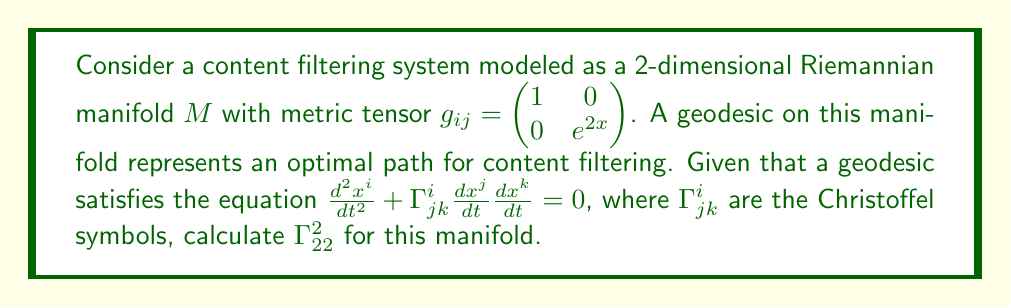Teach me how to tackle this problem. To calculate $\Gamma^2_{22}$, we'll follow these steps:

1) First, recall the formula for Christoffel symbols:

   $$\Gamma^i_{jk} = \frac{1}{2}g^{im}(\partial_j g_{mk} + \partial_k g_{mj} - \partial_m g_{jk})$$

2) For $\Gamma^2_{22}$, we need to calculate:

   $$\Gamma^2_{22} = \frac{1}{2}g^{2m}(\partial_2 g_{m2} + \partial_2 g_{m2} - \partial_m g_{22})$$

3) From the given metric tensor, we know that $g_{22} = e^{2x}$. Also, $g^{22} = e^{-2x}$ (the inverse of $g_{22}$).

4) Simplify the expression:

   $$\Gamma^2_{22} = \frac{1}{2}g^{22}(-\partial_2 g_{22})$$

   This is because $\partial_2 g_{m2} = 0$ for both $m=1$ and $m=2$, as $g_{12} = 0$ and $g_{22}$ doesn't depend on $y$ (which is what $\partial_2$ represents).

5) Calculate $\partial_2 g_{22}$:

   $$\partial_2 g_{22} = \partial_2 (e^{2x}) = 0$$

   This is because $e^{2x}$ doesn't depend on $y$.

6) Substitute into the formula:

   $$\Gamma^2_{22} = \frac{1}{2}e^{-2x}(0) = 0$$

Therefore, $\Gamma^2_{22} = 0$ for this manifold.
Answer: $0$ 